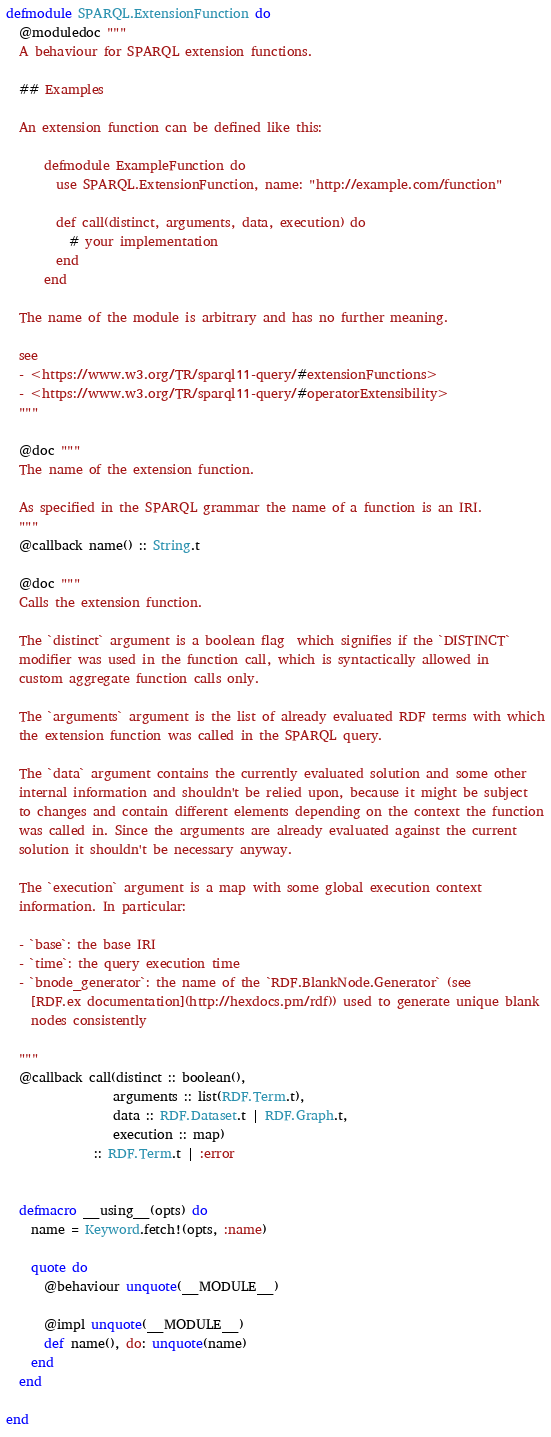Convert code to text. <code><loc_0><loc_0><loc_500><loc_500><_Elixir_>defmodule SPARQL.ExtensionFunction do
  @moduledoc """
  A behaviour for SPARQL extension functions.

  ## Examples

  An extension function can be defined like this:

      defmodule ExampleFunction do
        use SPARQL.ExtensionFunction, name: "http://example.com/function"

        def call(distinct, arguments, data, execution) do
          # your implementation
        end
      end

  The name of the module is arbitrary and has no further meaning.

  see
  - <https://www.w3.org/TR/sparql11-query/#extensionFunctions>
  - <https://www.w3.org/TR/sparql11-query/#operatorExtensibility>
  """

  @doc """
  The name of the extension function.

  As specified in the SPARQL grammar the name of a function is an IRI.
  """
  @callback name() :: String.t

  @doc """
  Calls the extension function.

  The `distinct` argument is a boolean flag  which signifies if the `DISTINCT`
  modifier was used in the function call, which is syntactically allowed in
  custom aggregate function calls only.

  The `arguments` argument is the list of already evaluated RDF terms with which
  the extension function was called in the SPARQL query.

  The `data` argument contains the currently evaluated solution and some other
  internal information and shouldn't be relied upon, because it might be subject
  to changes and contain different elements depending on the context the function
  was called in. Since the arguments are already evaluated against the current
  solution it shouldn't be necessary anyway.

  The `execution` argument is a map with some global execution context
  information. In particular:

  - `base`: the base IRI
  - `time`: the query execution time
  - `bnode_generator`: the name of the `RDF.BlankNode.Generator` (see
    [RDF.ex documentation](http://hexdocs.pm/rdf)) used to generate unique blank
    nodes consistently

  """
  @callback call(distinct :: boolean(),
                 arguments :: list(RDF.Term.t),
                 data :: RDF.Dataset.t | RDF.Graph.t,
                 execution :: map)
              :: RDF.Term.t | :error


  defmacro __using__(opts) do
    name = Keyword.fetch!(opts, :name)

    quote do
      @behaviour unquote(__MODULE__)

      @impl unquote(__MODULE__)
      def name(), do: unquote(name)
    end
  end

end
</code> 